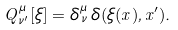<formula> <loc_0><loc_0><loc_500><loc_500>Q _ { \, \nu ^ { \prime } } ^ { \mu } [ \xi ] = \delta _ { \, \nu } ^ { \mu } \, \delta ( \xi ( x ) , x ^ { \prime } ) .</formula> 